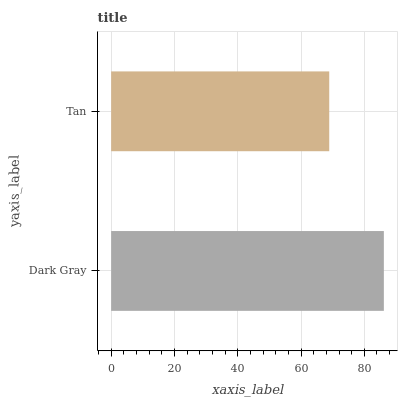Is Tan the minimum?
Answer yes or no. Yes. Is Dark Gray the maximum?
Answer yes or no. Yes. Is Tan the maximum?
Answer yes or no. No. Is Dark Gray greater than Tan?
Answer yes or no. Yes. Is Tan less than Dark Gray?
Answer yes or no. Yes. Is Tan greater than Dark Gray?
Answer yes or no. No. Is Dark Gray less than Tan?
Answer yes or no. No. Is Dark Gray the high median?
Answer yes or no. Yes. Is Tan the low median?
Answer yes or no. Yes. Is Tan the high median?
Answer yes or no. No. Is Dark Gray the low median?
Answer yes or no. No. 